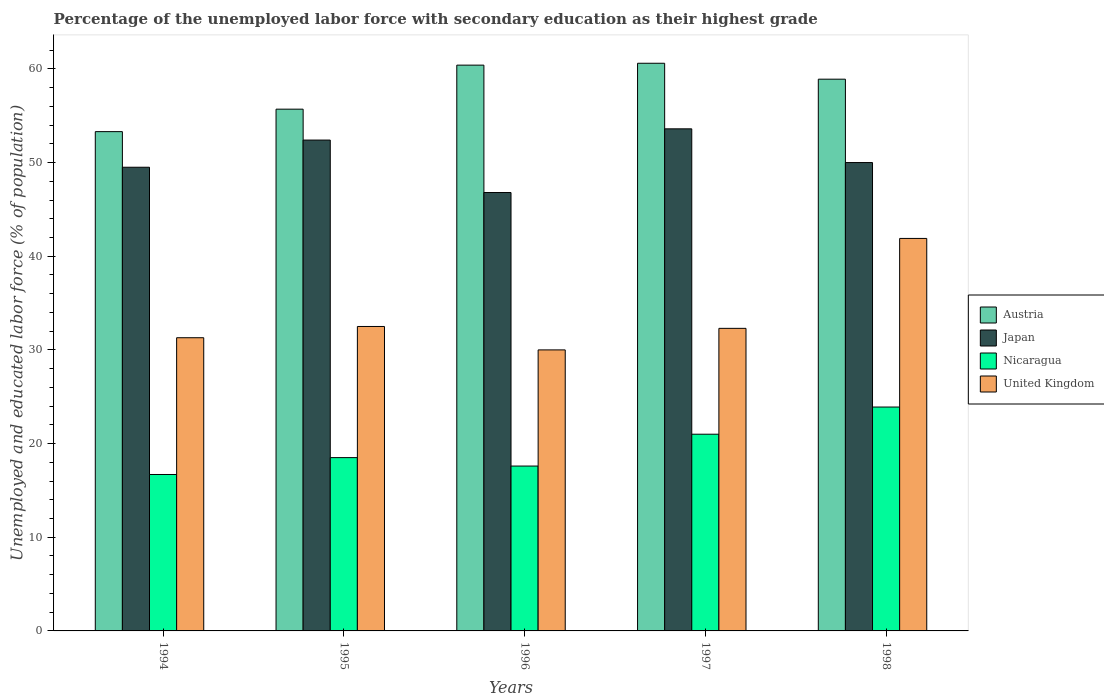How many groups of bars are there?
Ensure brevity in your answer.  5. How many bars are there on the 2nd tick from the left?
Offer a terse response. 4. How many bars are there on the 2nd tick from the right?
Give a very brief answer. 4. What is the label of the 2nd group of bars from the left?
Your response must be concise. 1995. In how many cases, is the number of bars for a given year not equal to the number of legend labels?
Make the answer very short. 0. What is the percentage of the unemployed labor force with secondary education in Austria in 1998?
Ensure brevity in your answer.  58.9. Across all years, what is the maximum percentage of the unemployed labor force with secondary education in Japan?
Ensure brevity in your answer.  53.6. Across all years, what is the minimum percentage of the unemployed labor force with secondary education in United Kingdom?
Keep it short and to the point. 30. In which year was the percentage of the unemployed labor force with secondary education in Austria minimum?
Give a very brief answer. 1994. What is the total percentage of the unemployed labor force with secondary education in Austria in the graph?
Keep it short and to the point. 288.9. What is the difference between the percentage of the unemployed labor force with secondary education in Japan in 1995 and that in 1996?
Your answer should be compact. 5.6. What is the difference between the percentage of the unemployed labor force with secondary education in Nicaragua in 1996 and the percentage of the unemployed labor force with secondary education in United Kingdom in 1994?
Provide a short and direct response. -13.7. What is the average percentage of the unemployed labor force with secondary education in Nicaragua per year?
Make the answer very short. 19.54. In the year 1994, what is the difference between the percentage of the unemployed labor force with secondary education in Austria and percentage of the unemployed labor force with secondary education in United Kingdom?
Offer a very short reply. 22. In how many years, is the percentage of the unemployed labor force with secondary education in Austria greater than 46 %?
Keep it short and to the point. 5. What is the ratio of the percentage of the unemployed labor force with secondary education in United Kingdom in 1995 to that in 1997?
Ensure brevity in your answer.  1.01. What is the difference between the highest and the second highest percentage of the unemployed labor force with secondary education in Japan?
Provide a short and direct response. 1.2. What is the difference between the highest and the lowest percentage of the unemployed labor force with secondary education in United Kingdom?
Your answer should be compact. 11.9. In how many years, is the percentage of the unemployed labor force with secondary education in Japan greater than the average percentage of the unemployed labor force with secondary education in Japan taken over all years?
Keep it short and to the point. 2. Is the sum of the percentage of the unemployed labor force with secondary education in United Kingdom in 1994 and 1998 greater than the maximum percentage of the unemployed labor force with secondary education in Austria across all years?
Your response must be concise. Yes. Is it the case that in every year, the sum of the percentage of the unemployed labor force with secondary education in United Kingdom and percentage of the unemployed labor force with secondary education in Nicaragua is greater than the sum of percentage of the unemployed labor force with secondary education in Austria and percentage of the unemployed labor force with secondary education in Japan?
Give a very brief answer. No. Is it the case that in every year, the sum of the percentage of the unemployed labor force with secondary education in United Kingdom and percentage of the unemployed labor force with secondary education in Nicaragua is greater than the percentage of the unemployed labor force with secondary education in Japan?
Your response must be concise. No. How many bars are there?
Your answer should be very brief. 20. How many years are there in the graph?
Offer a very short reply. 5. What is the difference between two consecutive major ticks on the Y-axis?
Offer a terse response. 10. Are the values on the major ticks of Y-axis written in scientific E-notation?
Keep it short and to the point. No. How many legend labels are there?
Provide a short and direct response. 4. How are the legend labels stacked?
Give a very brief answer. Vertical. What is the title of the graph?
Offer a very short reply. Percentage of the unemployed labor force with secondary education as their highest grade. Does "Cote d'Ivoire" appear as one of the legend labels in the graph?
Keep it short and to the point. No. What is the label or title of the Y-axis?
Provide a short and direct response. Unemployed and educated labor force (% of population). What is the Unemployed and educated labor force (% of population) of Austria in 1994?
Provide a succinct answer. 53.3. What is the Unemployed and educated labor force (% of population) in Japan in 1994?
Give a very brief answer. 49.5. What is the Unemployed and educated labor force (% of population) in Nicaragua in 1994?
Provide a succinct answer. 16.7. What is the Unemployed and educated labor force (% of population) in United Kingdom in 1994?
Offer a very short reply. 31.3. What is the Unemployed and educated labor force (% of population) in Austria in 1995?
Keep it short and to the point. 55.7. What is the Unemployed and educated labor force (% of population) in Japan in 1995?
Offer a terse response. 52.4. What is the Unemployed and educated labor force (% of population) of Nicaragua in 1995?
Make the answer very short. 18.5. What is the Unemployed and educated labor force (% of population) of United Kingdom in 1995?
Offer a terse response. 32.5. What is the Unemployed and educated labor force (% of population) of Austria in 1996?
Your answer should be compact. 60.4. What is the Unemployed and educated labor force (% of population) in Japan in 1996?
Your answer should be compact. 46.8. What is the Unemployed and educated labor force (% of population) in Nicaragua in 1996?
Your response must be concise. 17.6. What is the Unemployed and educated labor force (% of population) of United Kingdom in 1996?
Your answer should be compact. 30. What is the Unemployed and educated labor force (% of population) in Austria in 1997?
Your answer should be very brief. 60.6. What is the Unemployed and educated labor force (% of population) of Japan in 1997?
Make the answer very short. 53.6. What is the Unemployed and educated labor force (% of population) in Nicaragua in 1997?
Provide a short and direct response. 21. What is the Unemployed and educated labor force (% of population) of United Kingdom in 1997?
Your answer should be compact. 32.3. What is the Unemployed and educated labor force (% of population) in Austria in 1998?
Give a very brief answer. 58.9. What is the Unemployed and educated labor force (% of population) of Nicaragua in 1998?
Offer a terse response. 23.9. What is the Unemployed and educated labor force (% of population) of United Kingdom in 1998?
Your response must be concise. 41.9. Across all years, what is the maximum Unemployed and educated labor force (% of population) in Austria?
Your answer should be compact. 60.6. Across all years, what is the maximum Unemployed and educated labor force (% of population) of Japan?
Your response must be concise. 53.6. Across all years, what is the maximum Unemployed and educated labor force (% of population) of Nicaragua?
Provide a succinct answer. 23.9. Across all years, what is the maximum Unemployed and educated labor force (% of population) in United Kingdom?
Provide a short and direct response. 41.9. Across all years, what is the minimum Unemployed and educated labor force (% of population) of Austria?
Ensure brevity in your answer.  53.3. Across all years, what is the minimum Unemployed and educated labor force (% of population) of Japan?
Offer a terse response. 46.8. Across all years, what is the minimum Unemployed and educated labor force (% of population) of Nicaragua?
Your answer should be compact. 16.7. Across all years, what is the minimum Unemployed and educated labor force (% of population) of United Kingdom?
Offer a very short reply. 30. What is the total Unemployed and educated labor force (% of population) of Austria in the graph?
Provide a short and direct response. 288.9. What is the total Unemployed and educated labor force (% of population) in Japan in the graph?
Give a very brief answer. 252.3. What is the total Unemployed and educated labor force (% of population) of Nicaragua in the graph?
Make the answer very short. 97.7. What is the total Unemployed and educated labor force (% of population) of United Kingdom in the graph?
Offer a very short reply. 168. What is the difference between the Unemployed and educated labor force (% of population) in United Kingdom in 1994 and that in 1995?
Your response must be concise. -1.2. What is the difference between the Unemployed and educated labor force (% of population) in United Kingdom in 1994 and that in 1996?
Your response must be concise. 1.3. What is the difference between the Unemployed and educated labor force (% of population) of Austria in 1994 and that in 1997?
Provide a short and direct response. -7.3. What is the difference between the Unemployed and educated labor force (% of population) of United Kingdom in 1994 and that in 1997?
Provide a short and direct response. -1. What is the difference between the Unemployed and educated labor force (% of population) in Austria in 1994 and that in 1998?
Your answer should be compact. -5.6. What is the difference between the Unemployed and educated labor force (% of population) in Nicaragua in 1994 and that in 1998?
Give a very brief answer. -7.2. What is the difference between the Unemployed and educated labor force (% of population) of United Kingdom in 1995 and that in 1996?
Your answer should be very brief. 2.5. What is the difference between the Unemployed and educated labor force (% of population) in Austria in 1995 and that in 1997?
Ensure brevity in your answer.  -4.9. What is the difference between the Unemployed and educated labor force (% of population) in United Kingdom in 1995 and that in 1997?
Your answer should be compact. 0.2. What is the difference between the Unemployed and educated labor force (% of population) of Austria in 1995 and that in 1998?
Offer a terse response. -3.2. What is the difference between the Unemployed and educated labor force (% of population) of Japan in 1995 and that in 1998?
Keep it short and to the point. 2.4. What is the difference between the Unemployed and educated labor force (% of population) in Austria in 1996 and that in 1997?
Your answer should be very brief. -0.2. What is the difference between the Unemployed and educated labor force (% of population) in Japan in 1996 and that in 1997?
Offer a terse response. -6.8. What is the difference between the Unemployed and educated labor force (% of population) of Nicaragua in 1996 and that in 1997?
Make the answer very short. -3.4. What is the difference between the Unemployed and educated labor force (% of population) in United Kingdom in 1996 and that in 1997?
Offer a terse response. -2.3. What is the difference between the Unemployed and educated labor force (% of population) of Austria in 1996 and that in 1998?
Provide a succinct answer. 1.5. What is the difference between the Unemployed and educated labor force (% of population) of United Kingdom in 1996 and that in 1998?
Offer a terse response. -11.9. What is the difference between the Unemployed and educated labor force (% of population) of Austria in 1997 and that in 1998?
Your answer should be very brief. 1.7. What is the difference between the Unemployed and educated labor force (% of population) in Japan in 1997 and that in 1998?
Offer a very short reply. 3.6. What is the difference between the Unemployed and educated labor force (% of population) in Nicaragua in 1997 and that in 1998?
Give a very brief answer. -2.9. What is the difference between the Unemployed and educated labor force (% of population) of United Kingdom in 1997 and that in 1998?
Provide a succinct answer. -9.6. What is the difference between the Unemployed and educated labor force (% of population) of Austria in 1994 and the Unemployed and educated labor force (% of population) of Japan in 1995?
Your answer should be compact. 0.9. What is the difference between the Unemployed and educated labor force (% of population) of Austria in 1994 and the Unemployed and educated labor force (% of population) of Nicaragua in 1995?
Offer a terse response. 34.8. What is the difference between the Unemployed and educated labor force (% of population) of Austria in 1994 and the Unemployed and educated labor force (% of population) of United Kingdom in 1995?
Ensure brevity in your answer.  20.8. What is the difference between the Unemployed and educated labor force (% of population) in Japan in 1994 and the Unemployed and educated labor force (% of population) in Nicaragua in 1995?
Offer a very short reply. 31. What is the difference between the Unemployed and educated labor force (% of population) of Nicaragua in 1994 and the Unemployed and educated labor force (% of population) of United Kingdom in 1995?
Provide a succinct answer. -15.8. What is the difference between the Unemployed and educated labor force (% of population) in Austria in 1994 and the Unemployed and educated labor force (% of population) in Nicaragua in 1996?
Give a very brief answer. 35.7. What is the difference between the Unemployed and educated labor force (% of population) in Austria in 1994 and the Unemployed and educated labor force (% of population) in United Kingdom in 1996?
Provide a short and direct response. 23.3. What is the difference between the Unemployed and educated labor force (% of population) of Japan in 1994 and the Unemployed and educated labor force (% of population) of Nicaragua in 1996?
Your response must be concise. 31.9. What is the difference between the Unemployed and educated labor force (% of population) of Austria in 1994 and the Unemployed and educated labor force (% of population) of Nicaragua in 1997?
Make the answer very short. 32.3. What is the difference between the Unemployed and educated labor force (% of population) of Japan in 1994 and the Unemployed and educated labor force (% of population) of Nicaragua in 1997?
Offer a terse response. 28.5. What is the difference between the Unemployed and educated labor force (% of population) of Nicaragua in 1994 and the Unemployed and educated labor force (% of population) of United Kingdom in 1997?
Ensure brevity in your answer.  -15.6. What is the difference between the Unemployed and educated labor force (% of population) in Austria in 1994 and the Unemployed and educated labor force (% of population) in Nicaragua in 1998?
Offer a very short reply. 29.4. What is the difference between the Unemployed and educated labor force (% of population) in Austria in 1994 and the Unemployed and educated labor force (% of population) in United Kingdom in 1998?
Ensure brevity in your answer.  11.4. What is the difference between the Unemployed and educated labor force (% of population) in Japan in 1994 and the Unemployed and educated labor force (% of population) in Nicaragua in 1998?
Provide a short and direct response. 25.6. What is the difference between the Unemployed and educated labor force (% of population) in Japan in 1994 and the Unemployed and educated labor force (% of population) in United Kingdom in 1998?
Your answer should be compact. 7.6. What is the difference between the Unemployed and educated labor force (% of population) of Nicaragua in 1994 and the Unemployed and educated labor force (% of population) of United Kingdom in 1998?
Offer a terse response. -25.2. What is the difference between the Unemployed and educated labor force (% of population) of Austria in 1995 and the Unemployed and educated labor force (% of population) of Nicaragua in 1996?
Offer a terse response. 38.1. What is the difference between the Unemployed and educated labor force (% of population) of Austria in 1995 and the Unemployed and educated labor force (% of population) of United Kingdom in 1996?
Provide a short and direct response. 25.7. What is the difference between the Unemployed and educated labor force (% of population) of Japan in 1995 and the Unemployed and educated labor force (% of population) of Nicaragua in 1996?
Give a very brief answer. 34.8. What is the difference between the Unemployed and educated labor force (% of population) of Japan in 1995 and the Unemployed and educated labor force (% of population) of United Kingdom in 1996?
Your response must be concise. 22.4. What is the difference between the Unemployed and educated labor force (% of population) in Nicaragua in 1995 and the Unemployed and educated labor force (% of population) in United Kingdom in 1996?
Keep it short and to the point. -11.5. What is the difference between the Unemployed and educated labor force (% of population) in Austria in 1995 and the Unemployed and educated labor force (% of population) in Japan in 1997?
Keep it short and to the point. 2.1. What is the difference between the Unemployed and educated labor force (% of population) in Austria in 1995 and the Unemployed and educated labor force (% of population) in Nicaragua in 1997?
Your answer should be compact. 34.7. What is the difference between the Unemployed and educated labor force (% of population) in Austria in 1995 and the Unemployed and educated labor force (% of population) in United Kingdom in 1997?
Provide a short and direct response. 23.4. What is the difference between the Unemployed and educated labor force (% of population) of Japan in 1995 and the Unemployed and educated labor force (% of population) of Nicaragua in 1997?
Make the answer very short. 31.4. What is the difference between the Unemployed and educated labor force (% of population) of Japan in 1995 and the Unemployed and educated labor force (% of population) of United Kingdom in 1997?
Your answer should be very brief. 20.1. What is the difference between the Unemployed and educated labor force (% of population) in Nicaragua in 1995 and the Unemployed and educated labor force (% of population) in United Kingdom in 1997?
Your answer should be compact. -13.8. What is the difference between the Unemployed and educated labor force (% of population) of Austria in 1995 and the Unemployed and educated labor force (% of population) of Japan in 1998?
Provide a short and direct response. 5.7. What is the difference between the Unemployed and educated labor force (% of population) in Austria in 1995 and the Unemployed and educated labor force (% of population) in Nicaragua in 1998?
Provide a succinct answer. 31.8. What is the difference between the Unemployed and educated labor force (% of population) in Austria in 1995 and the Unemployed and educated labor force (% of population) in United Kingdom in 1998?
Ensure brevity in your answer.  13.8. What is the difference between the Unemployed and educated labor force (% of population) of Japan in 1995 and the Unemployed and educated labor force (% of population) of Nicaragua in 1998?
Make the answer very short. 28.5. What is the difference between the Unemployed and educated labor force (% of population) in Nicaragua in 1995 and the Unemployed and educated labor force (% of population) in United Kingdom in 1998?
Your response must be concise. -23.4. What is the difference between the Unemployed and educated labor force (% of population) of Austria in 1996 and the Unemployed and educated labor force (% of population) of Japan in 1997?
Offer a very short reply. 6.8. What is the difference between the Unemployed and educated labor force (% of population) of Austria in 1996 and the Unemployed and educated labor force (% of population) of Nicaragua in 1997?
Provide a succinct answer. 39.4. What is the difference between the Unemployed and educated labor force (% of population) of Austria in 1996 and the Unemployed and educated labor force (% of population) of United Kingdom in 1997?
Your answer should be compact. 28.1. What is the difference between the Unemployed and educated labor force (% of population) in Japan in 1996 and the Unemployed and educated labor force (% of population) in Nicaragua in 1997?
Your answer should be compact. 25.8. What is the difference between the Unemployed and educated labor force (% of population) of Japan in 1996 and the Unemployed and educated labor force (% of population) of United Kingdom in 1997?
Offer a very short reply. 14.5. What is the difference between the Unemployed and educated labor force (% of population) in Nicaragua in 1996 and the Unemployed and educated labor force (% of population) in United Kingdom in 1997?
Provide a short and direct response. -14.7. What is the difference between the Unemployed and educated labor force (% of population) of Austria in 1996 and the Unemployed and educated labor force (% of population) of Japan in 1998?
Ensure brevity in your answer.  10.4. What is the difference between the Unemployed and educated labor force (% of population) in Austria in 1996 and the Unemployed and educated labor force (% of population) in Nicaragua in 1998?
Give a very brief answer. 36.5. What is the difference between the Unemployed and educated labor force (% of population) in Austria in 1996 and the Unemployed and educated labor force (% of population) in United Kingdom in 1998?
Make the answer very short. 18.5. What is the difference between the Unemployed and educated labor force (% of population) of Japan in 1996 and the Unemployed and educated labor force (% of population) of Nicaragua in 1998?
Make the answer very short. 22.9. What is the difference between the Unemployed and educated labor force (% of population) of Japan in 1996 and the Unemployed and educated labor force (% of population) of United Kingdom in 1998?
Your response must be concise. 4.9. What is the difference between the Unemployed and educated labor force (% of population) of Nicaragua in 1996 and the Unemployed and educated labor force (% of population) of United Kingdom in 1998?
Your answer should be very brief. -24.3. What is the difference between the Unemployed and educated labor force (% of population) in Austria in 1997 and the Unemployed and educated labor force (% of population) in Japan in 1998?
Keep it short and to the point. 10.6. What is the difference between the Unemployed and educated labor force (% of population) in Austria in 1997 and the Unemployed and educated labor force (% of population) in Nicaragua in 1998?
Offer a terse response. 36.7. What is the difference between the Unemployed and educated labor force (% of population) in Austria in 1997 and the Unemployed and educated labor force (% of population) in United Kingdom in 1998?
Provide a succinct answer. 18.7. What is the difference between the Unemployed and educated labor force (% of population) in Japan in 1997 and the Unemployed and educated labor force (% of population) in Nicaragua in 1998?
Your response must be concise. 29.7. What is the difference between the Unemployed and educated labor force (% of population) in Japan in 1997 and the Unemployed and educated labor force (% of population) in United Kingdom in 1998?
Give a very brief answer. 11.7. What is the difference between the Unemployed and educated labor force (% of population) in Nicaragua in 1997 and the Unemployed and educated labor force (% of population) in United Kingdom in 1998?
Your answer should be very brief. -20.9. What is the average Unemployed and educated labor force (% of population) in Austria per year?
Your answer should be very brief. 57.78. What is the average Unemployed and educated labor force (% of population) of Japan per year?
Provide a short and direct response. 50.46. What is the average Unemployed and educated labor force (% of population) of Nicaragua per year?
Your answer should be compact. 19.54. What is the average Unemployed and educated labor force (% of population) of United Kingdom per year?
Give a very brief answer. 33.6. In the year 1994, what is the difference between the Unemployed and educated labor force (% of population) in Austria and Unemployed and educated labor force (% of population) in Japan?
Your response must be concise. 3.8. In the year 1994, what is the difference between the Unemployed and educated labor force (% of population) in Austria and Unemployed and educated labor force (% of population) in Nicaragua?
Provide a short and direct response. 36.6. In the year 1994, what is the difference between the Unemployed and educated labor force (% of population) in Austria and Unemployed and educated labor force (% of population) in United Kingdom?
Your response must be concise. 22. In the year 1994, what is the difference between the Unemployed and educated labor force (% of population) of Japan and Unemployed and educated labor force (% of population) of Nicaragua?
Give a very brief answer. 32.8. In the year 1994, what is the difference between the Unemployed and educated labor force (% of population) in Japan and Unemployed and educated labor force (% of population) in United Kingdom?
Make the answer very short. 18.2. In the year 1994, what is the difference between the Unemployed and educated labor force (% of population) of Nicaragua and Unemployed and educated labor force (% of population) of United Kingdom?
Make the answer very short. -14.6. In the year 1995, what is the difference between the Unemployed and educated labor force (% of population) of Austria and Unemployed and educated labor force (% of population) of Nicaragua?
Offer a terse response. 37.2. In the year 1995, what is the difference between the Unemployed and educated labor force (% of population) of Austria and Unemployed and educated labor force (% of population) of United Kingdom?
Make the answer very short. 23.2. In the year 1995, what is the difference between the Unemployed and educated labor force (% of population) in Japan and Unemployed and educated labor force (% of population) in Nicaragua?
Give a very brief answer. 33.9. In the year 1995, what is the difference between the Unemployed and educated labor force (% of population) of Japan and Unemployed and educated labor force (% of population) of United Kingdom?
Keep it short and to the point. 19.9. In the year 1996, what is the difference between the Unemployed and educated labor force (% of population) of Austria and Unemployed and educated labor force (% of population) of Nicaragua?
Ensure brevity in your answer.  42.8. In the year 1996, what is the difference between the Unemployed and educated labor force (% of population) in Austria and Unemployed and educated labor force (% of population) in United Kingdom?
Provide a succinct answer. 30.4. In the year 1996, what is the difference between the Unemployed and educated labor force (% of population) in Japan and Unemployed and educated labor force (% of population) in Nicaragua?
Offer a terse response. 29.2. In the year 1996, what is the difference between the Unemployed and educated labor force (% of population) in Japan and Unemployed and educated labor force (% of population) in United Kingdom?
Keep it short and to the point. 16.8. In the year 1997, what is the difference between the Unemployed and educated labor force (% of population) of Austria and Unemployed and educated labor force (% of population) of Japan?
Ensure brevity in your answer.  7. In the year 1997, what is the difference between the Unemployed and educated labor force (% of population) in Austria and Unemployed and educated labor force (% of population) in Nicaragua?
Provide a short and direct response. 39.6. In the year 1997, what is the difference between the Unemployed and educated labor force (% of population) in Austria and Unemployed and educated labor force (% of population) in United Kingdom?
Provide a succinct answer. 28.3. In the year 1997, what is the difference between the Unemployed and educated labor force (% of population) in Japan and Unemployed and educated labor force (% of population) in Nicaragua?
Your answer should be very brief. 32.6. In the year 1997, what is the difference between the Unemployed and educated labor force (% of population) in Japan and Unemployed and educated labor force (% of population) in United Kingdom?
Provide a succinct answer. 21.3. In the year 1998, what is the difference between the Unemployed and educated labor force (% of population) of Japan and Unemployed and educated labor force (% of population) of Nicaragua?
Make the answer very short. 26.1. In the year 1998, what is the difference between the Unemployed and educated labor force (% of population) in Nicaragua and Unemployed and educated labor force (% of population) in United Kingdom?
Offer a very short reply. -18. What is the ratio of the Unemployed and educated labor force (% of population) in Austria in 1994 to that in 1995?
Your response must be concise. 0.96. What is the ratio of the Unemployed and educated labor force (% of population) in Japan in 1994 to that in 1995?
Your response must be concise. 0.94. What is the ratio of the Unemployed and educated labor force (% of population) in Nicaragua in 1994 to that in 1995?
Ensure brevity in your answer.  0.9. What is the ratio of the Unemployed and educated labor force (% of population) of United Kingdom in 1994 to that in 1995?
Offer a very short reply. 0.96. What is the ratio of the Unemployed and educated labor force (% of population) in Austria in 1994 to that in 1996?
Keep it short and to the point. 0.88. What is the ratio of the Unemployed and educated labor force (% of population) in Japan in 1994 to that in 1996?
Your response must be concise. 1.06. What is the ratio of the Unemployed and educated labor force (% of population) in Nicaragua in 1994 to that in 1996?
Give a very brief answer. 0.95. What is the ratio of the Unemployed and educated labor force (% of population) of United Kingdom in 1994 to that in 1996?
Provide a short and direct response. 1.04. What is the ratio of the Unemployed and educated labor force (% of population) of Austria in 1994 to that in 1997?
Your response must be concise. 0.88. What is the ratio of the Unemployed and educated labor force (% of population) of Japan in 1994 to that in 1997?
Give a very brief answer. 0.92. What is the ratio of the Unemployed and educated labor force (% of population) in Nicaragua in 1994 to that in 1997?
Your answer should be very brief. 0.8. What is the ratio of the Unemployed and educated labor force (% of population) of United Kingdom in 1994 to that in 1997?
Give a very brief answer. 0.97. What is the ratio of the Unemployed and educated labor force (% of population) in Austria in 1994 to that in 1998?
Give a very brief answer. 0.9. What is the ratio of the Unemployed and educated labor force (% of population) of Nicaragua in 1994 to that in 1998?
Make the answer very short. 0.7. What is the ratio of the Unemployed and educated labor force (% of population) of United Kingdom in 1994 to that in 1998?
Your response must be concise. 0.75. What is the ratio of the Unemployed and educated labor force (% of population) of Austria in 1995 to that in 1996?
Keep it short and to the point. 0.92. What is the ratio of the Unemployed and educated labor force (% of population) in Japan in 1995 to that in 1996?
Offer a terse response. 1.12. What is the ratio of the Unemployed and educated labor force (% of population) in Nicaragua in 1995 to that in 1996?
Keep it short and to the point. 1.05. What is the ratio of the Unemployed and educated labor force (% of population) of Austria in 1995 to that in 1997?
Ensure brevity in your answer.  0.92. What is the ratio of the Unemployed and educated labor force (% of population) of Japan in 1995 to that in 1997?
Keep it short and to the point. 0.98. What is the ratio of the Unemployed and educated labor force (% of population) in Nicaragua in 1995 to that in 1997?
Offer a terse response. 0.88. What is the ratio of the Unemployed and educated labor force (% of population) of Austria in 1995 to that in 1998?
Make the answer very short. 0.95. What is the ratio of the Unemployed and educated labor force (% of population) of Japan in 1995 to that in 1998?
Offer a terse response. 1.05. What is the ratio of the Unemployed and educated labor force (% of population) in Nicaragua in 1995 to that in 1998?
Your answer should be very brief. 0.77. What is the ratio of the Unemployed and educated labor force (% of population) in United Kingdom in 1995 to that in 1998?
Your answer should be compact. 0.78. What is the ratio of the Unemployed and educated labor force (% of population) in Japan in 1996 to that in 1997?
Offer a very short reply. 0.87. What is the ratio of the Unemployed and educated labor force (% of population) in Nicaragua in 1996 to that in 1997?
Offer a very short reply. 0.84. What is the ratio of the Unemployed and educated labor force (% of population) of United Kingdom in 1996 to that in 1997?
Offer a very short reply. 0.93. What is the ratio of the Unemployed and educated labor force (% of population) of Austria in 1996 to that in 1998?
Make the answer very short. 1.03. What is the ratio of the Unemployed and educated labor force (% of population) of Japan in 1996 to that in 1998?
Your response must be concise. 0.94. What is the ratio of the Unemployed and educated labor force (% of population) in Nicaragua in 1996 to that in 1998?
Provide a short and direct response. 0.74. What is the ratio of the Unemployed and educated labor force (% of population) in United Kingdom in 1996 to that in 1998?
Offer a terse response. 0.72. What is the ratio of the Unemployed and educated labor force (% of population) in Austria in 1997 to that in 1998?
Your answer should be very brief. 1.03. What is the ratio of the Unemployed and educated labor force (% of population) in Japan in 1997 to that in 1998?
Offer a terse response. 1.07. What is the ratio of the Unemployed and educated labor force (% of population) in Nicaragua in 1997 to that in 1998?
Keep it short and to the point. 0.88. What is the ratio of the Unemployed and educated labor force (% of population) in United Kingdom in 1997 to that in 1998?
Ensure brevity in your answer.  0.77. What is the difference between the highest and the second highest Unemployed and educated labor force (% of population) in Austria?
Offer a terse response. 0.2. What is the difference between the highest and the second highest Unemployed and educated labor force (% of population) of Japan?
Provide a short and direct response. 1.2. What is the difference between the highest and the second highest Unemployed and educated labor force (% of population) of Nicaragua?
Give a very brief answer. 2.9. What is the difference between the highest and the second highest Unemployed and educated labor force (% of population) in United Kingdom?
Make the answer very short. 9.4. What is the difference between the highest and the lowest Unemployed and educated labor force (% of population) in Nicaragua?
Provide a succinct answer. 7.2. 